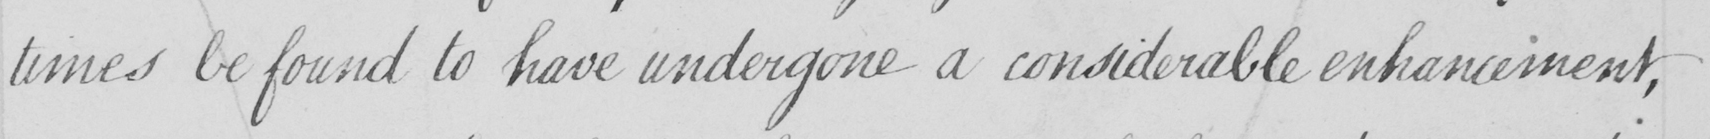Can you tell me what this handwritten text says? times be found to have undergone a considerable enhancement , 